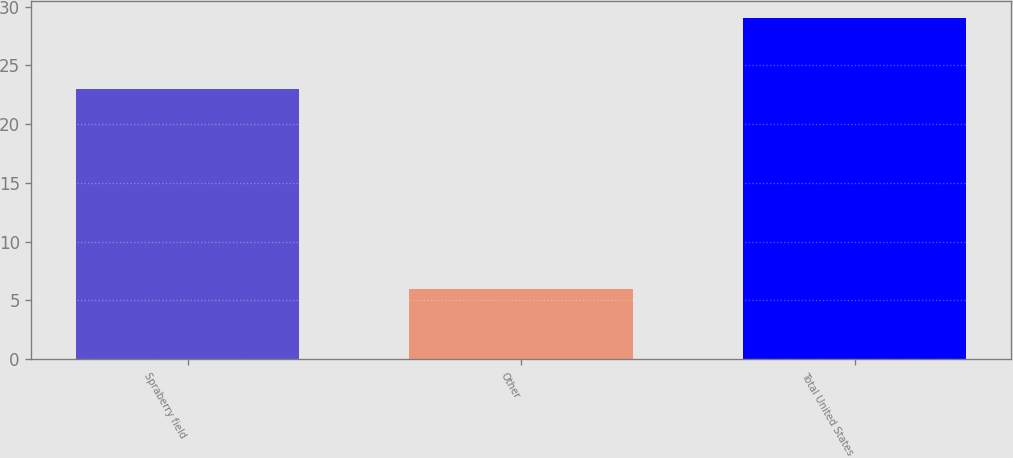Convert chart to OTSL. <chart><loc_0><loc_0><loc_500><loc_500><bar_chart><fcel>Spraberry field<fcel>Other<fcel>Total United States<nl><fcel>23<fcel>6<fcel>29<nl></chart> 